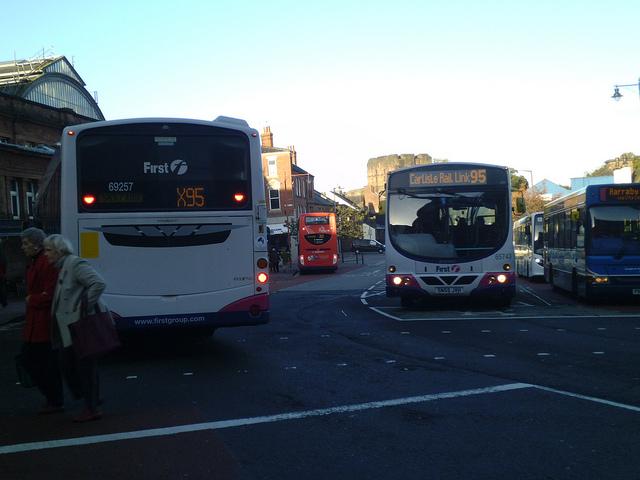How many people are  there?
Keep it brief. 2. What is the company displayed on the buses?
Give a very brief answer. First. How many red buses are there?
Write a very short answer. 1. Is this picture taken in a train yard?
Give a very brief answer. No. 